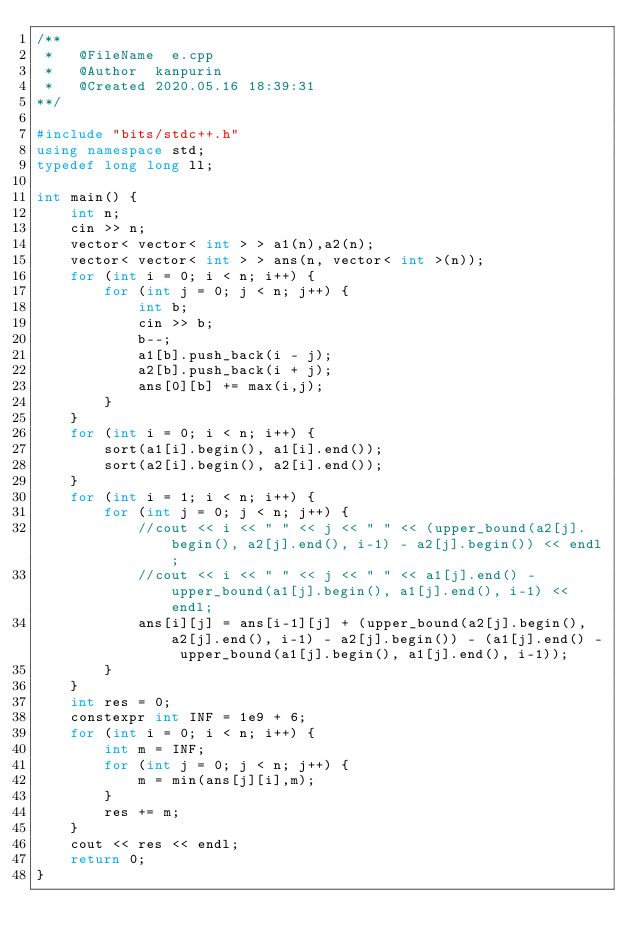<code> <loc_0><loc_0><loc_500><loc_500><_C++_>/**
 *   @FileName	e.cpp
 *   @Author	kanpurin
 *   @Created	2020.05.16 18:39:31
**/

#include "bits/stdc++.h" 
using namespace std; 
typedef long long ll;

int main() {
    int n;
    cin >> n;
    vector< vector< int > > a1(n),a2(n);
    vector< vector< int > > ans(n, vector< int >(n));
    for (int i = 0; i < n; i++) {
        for (int j = 0; j < n; j++) {
            int b;
            cin >> b;
            b--;
            a1[b].push_back(i - j);
            a2[b].push_back(i + j);
            ans[0][b] += max(i,j);
        }
    }
    for (int i = 0; i < n; i++) {
        sort(a1[i].begin(), a1[i].end());
        sort(a2[i].begin(), a2[i].end());
    }
    for (int i = 1; i < n; i++) {
        for (int j = 0; j < n; j++) {
            //cout << i << " " << j << " " << (upper_bound(a2[j].begin(), a2[j].end(), i-1) - a2[j].begin()) << endl;
            //cout << i << " " << j << " " << a1[j].end() - upper_bound(a1[j].begin(), a1[j].end(), i-1) << endl;
            ans[i][j] = ans[i-1][j] + (upper_bound(a2[j].begin(), a2[j].end(), i-1) - a2[j].begin()) - (a1[j].end() - upper_bound(a1[j].begin(), a1[j].end(), i-1));
        }
    }
    int res = 0;
    constexpr int INF = 1e9 + 6;
    for (int i = 0; i < n; i++) {
        int m = INF;
        for (int j = 0; j < n; j++) {
            m = min(ans[j][i],m);
        }
        res += m;
    }
    cout << res << endl;
    return 0;
}</code> 